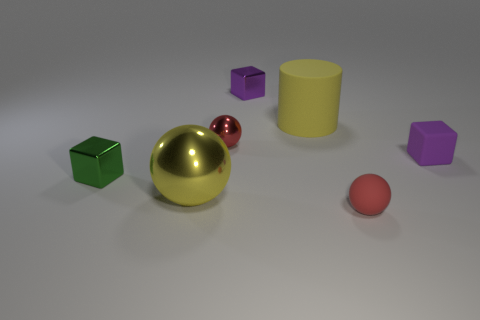The purple matte thing that is the same shape as the tiny purple metal thing is what size?
Provide a succinct answer. Small. There is a tiny shiny cube that is behind the yellow matte object; what number of small purple things are in front of it?
Ensure brevity in your answer.  1. Do the ball behind the tiny purple matte block and the small sphere that is to the right of the purple shiny cube have the same material?
Give a very brief answer. No. What number of metallic objects have the same shape as the tiny purple matte object?
Your response must be concise. 2. How many tiny metallic blocks are the same color as the large shiny sphere?
Offer a terse response. 0. There is a big yellow object right of the yellow sphere; is it the same shape as the red object behind the green cube?
Offer a terse response. No. There is a matte thing to the right of the small thing that is in front of the yellow metal ball; how many small balls are right of it?
Provide a short and direct response. 0. There is a tiny red ball on the left side of the big rubber cylinder that is behind the object that is in front of the yellow metallic sphere; what is its material?
Provide a short and direct response. Metal. Is the material of the small red object that is behind the green cube the same as the big yellow cylinder?
Provide a short and direct response. No. What number of other green metal cubes have the same size as the green metallic cube?
Offer a very short reply. 0. 